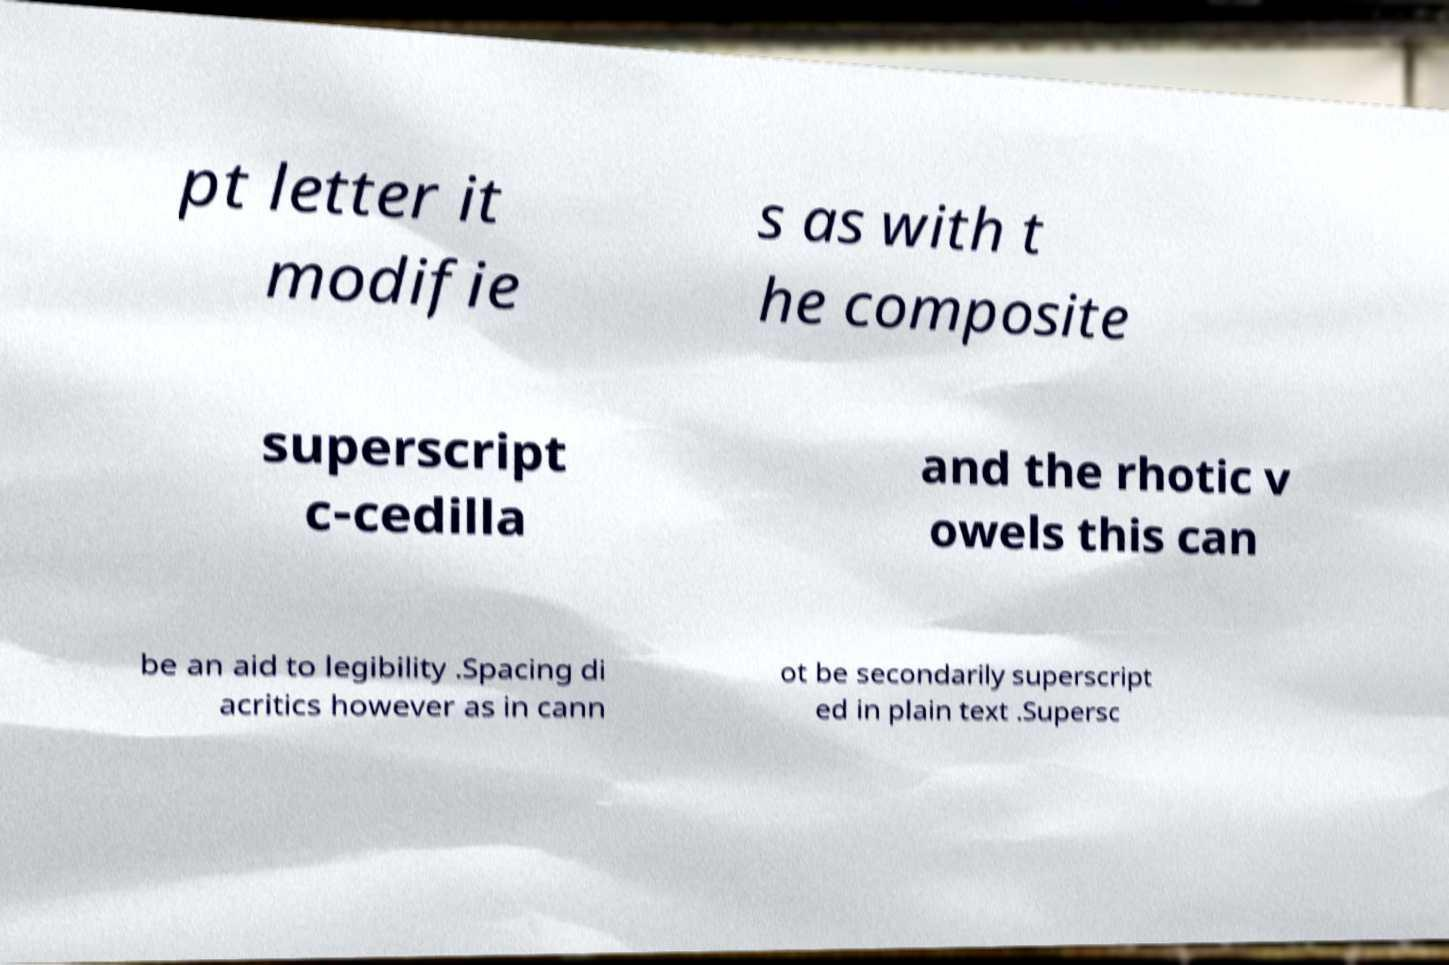Can you read and provide the text displayed in the image?This photo seems to have some interesting text. Can you extract and type it out for me? pt letter it modifie s as with t he composite superscript c-cedilla and the rhotic v owels this can be an aid to legibility .Spacing di acritics however as in cann ot be secondarily superscript ed in plain text .Supersc 